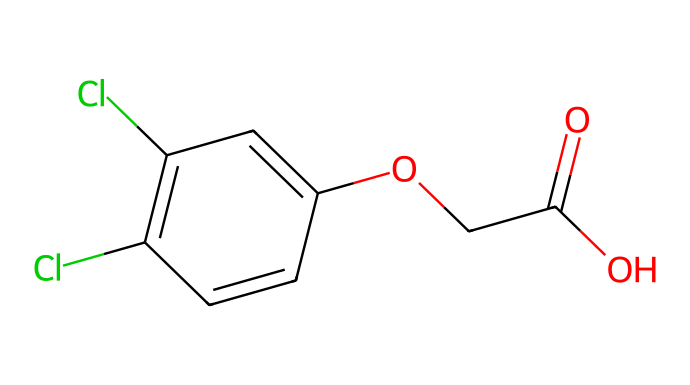What is the molecular formula of 2,4-D? To determine the molecular formula, we need to identify the elements and their counts in the structure represented by the SMILES. The structure shows a combination of carbon (C), hydrogen (H), chlorine (Cl), and oxygen (O) atoms, specifically, there are 8 carbon atoms, 7 hydrogen atoms, 2 chlorine atoms, and 4 oxygen atoms. Therefore, the molecular formula is C8H6Cl2O3.
Answer: C8H6Cl2O3 How many carbon atoms are in 2,4-D? By analyzing the structure from the SMILES representation, we can count the carbon atoms. The molecule has 8 carbon atoms connected in a specific arrangement. Hence, there are 8 carbon atoms.
Answer: 8 What is the role of chlorine in 2,4-D? The chlorine atoms in the structure serve to increase the herbicidal efficacy of 2,4-D by altering its biological activity, which helps the herbicide selectively target certain plant growth processes while minimizing harm to desirable plants.
Answer: herbicidal efficacy Does 2,4-D contain any functional groups? Yes, the presence of -COOH (carboxylic acid) and ether (-O-) in the structure indicates that 2,4-D contains functional groups. The -COOH group contributes to its herbicidal properties.
Answer: yes How does the structure of 2,4-D contribute to its selectivity as a herbicide? The selectivity of 2,4-D as a herbicide is mainly due to its structural similarity to plant hormones called auxins. The presence of specific functional groups, like the phenoxy and carboxylic acid groups, allows it to mimic these hormones, thus affecting only broadleaf plants while leaving grasses unharmed.
Answer: structural mimicry What type of bond connects the chlorine atoms to the carbon atoms in 2,4-D? In the structure of 2,4-D, the chlorine atoms are connected to the carbon atoms through single covalent bonds, known as carbon-chlorine (C-Cl) bonds, which are typical in halogenated compounds.
Answer: single covalent bonds What is the typical use of 2,4-D in agriculture? 2,4-D is commonly used as a selective herbicide effective against broadleaf weeds while being safe for crops like corn, wheat, and rice, which is key for weed management in various agricultural practices.
Answer: selective herbicide 